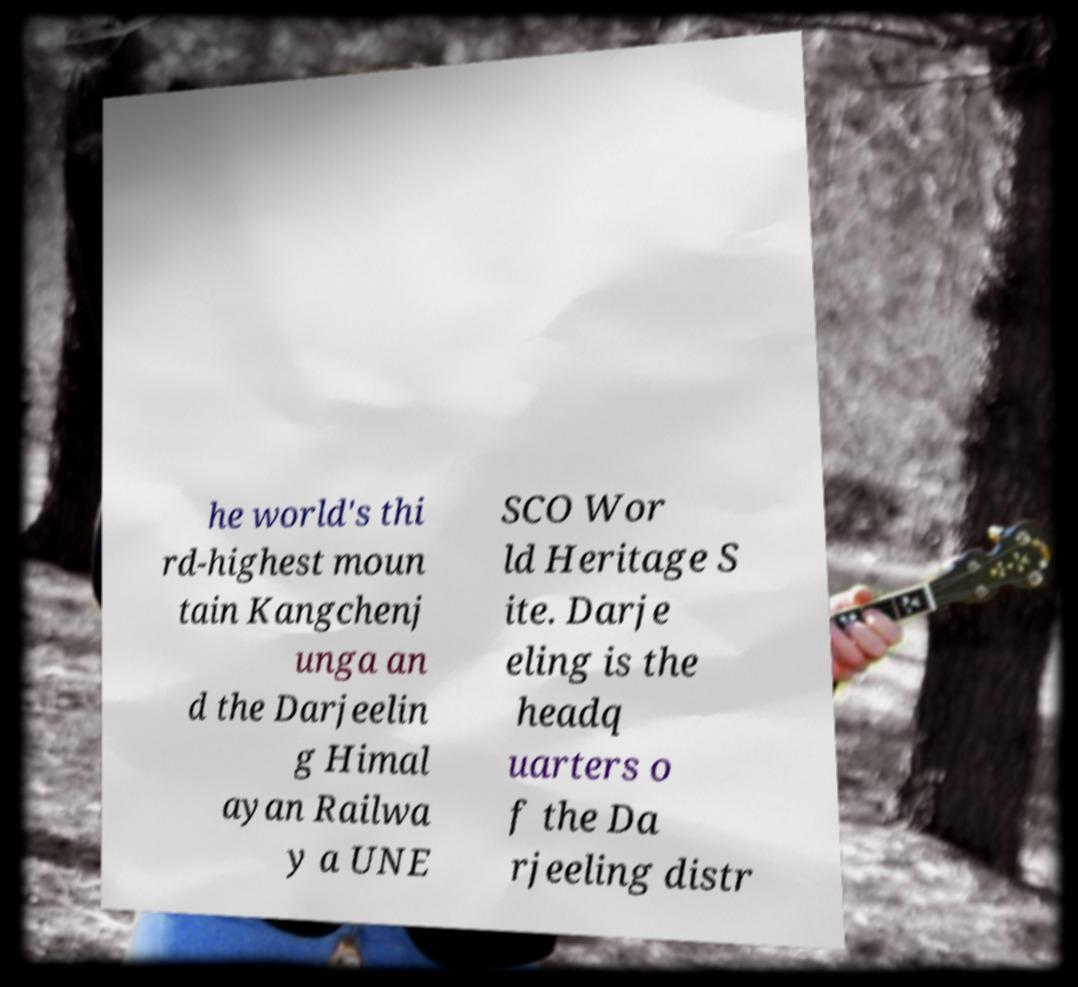Could you assist in decoding the text presented in this image and type it out clearly? he world's thi rd-highest moun tain Kangchenj unga an d the Darjeelin g Himal ayan Railwa y a UNE SCO Wor ld Heritage S ite. Darje eling is the headq uarters o f the Da rjeeling distr 